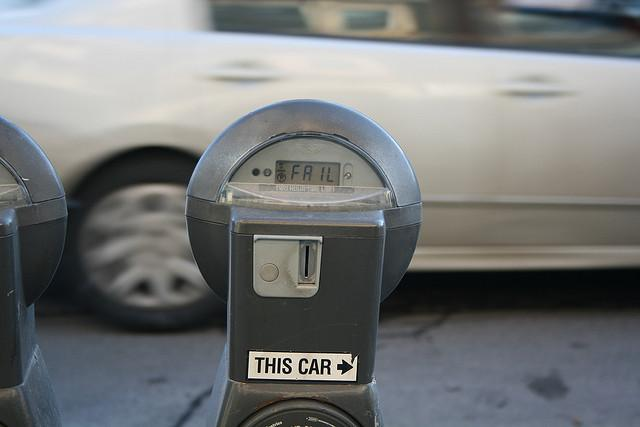Which direction is this meter pointing towards? right 